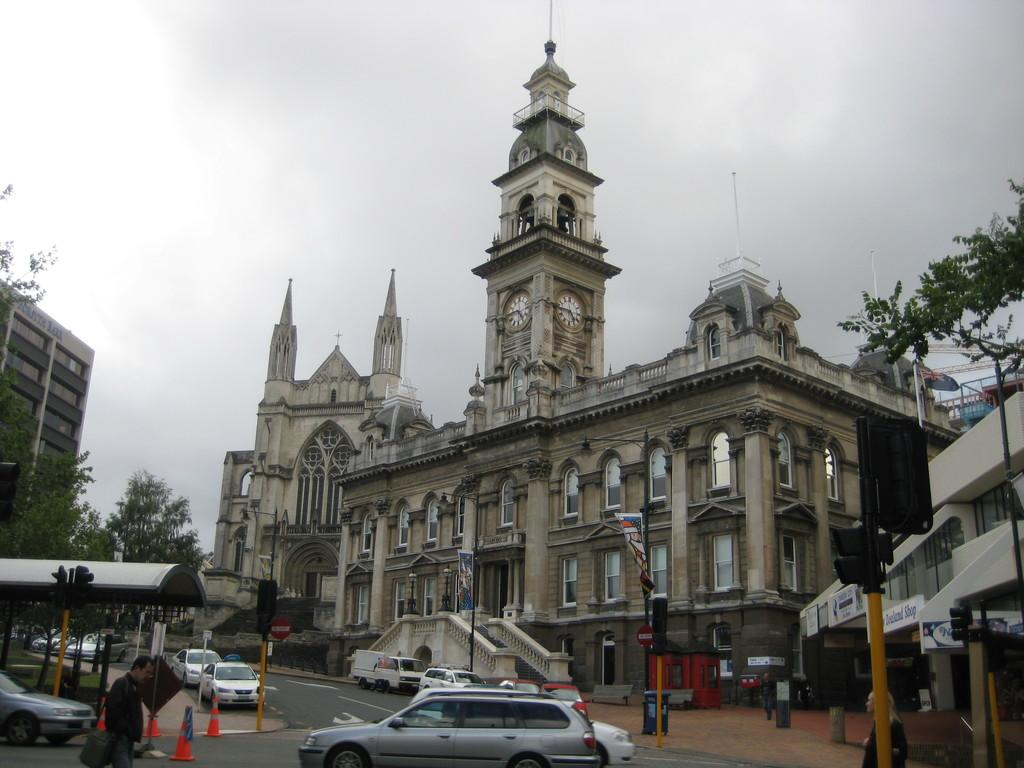What type of structure is depicted in the image? There is a building with a clock tower in the image. What can be seen in front of the building? There are vehicles in front of the building. What type of vegetation is present in the image? There are trees in the left corner of the image. What type of bulb is used to light up the clock tower in the image? There is no information about the type of bulb used to light up the clock tower in the image. Additionally, the image does not show any bulbs or lighting fixtures. 